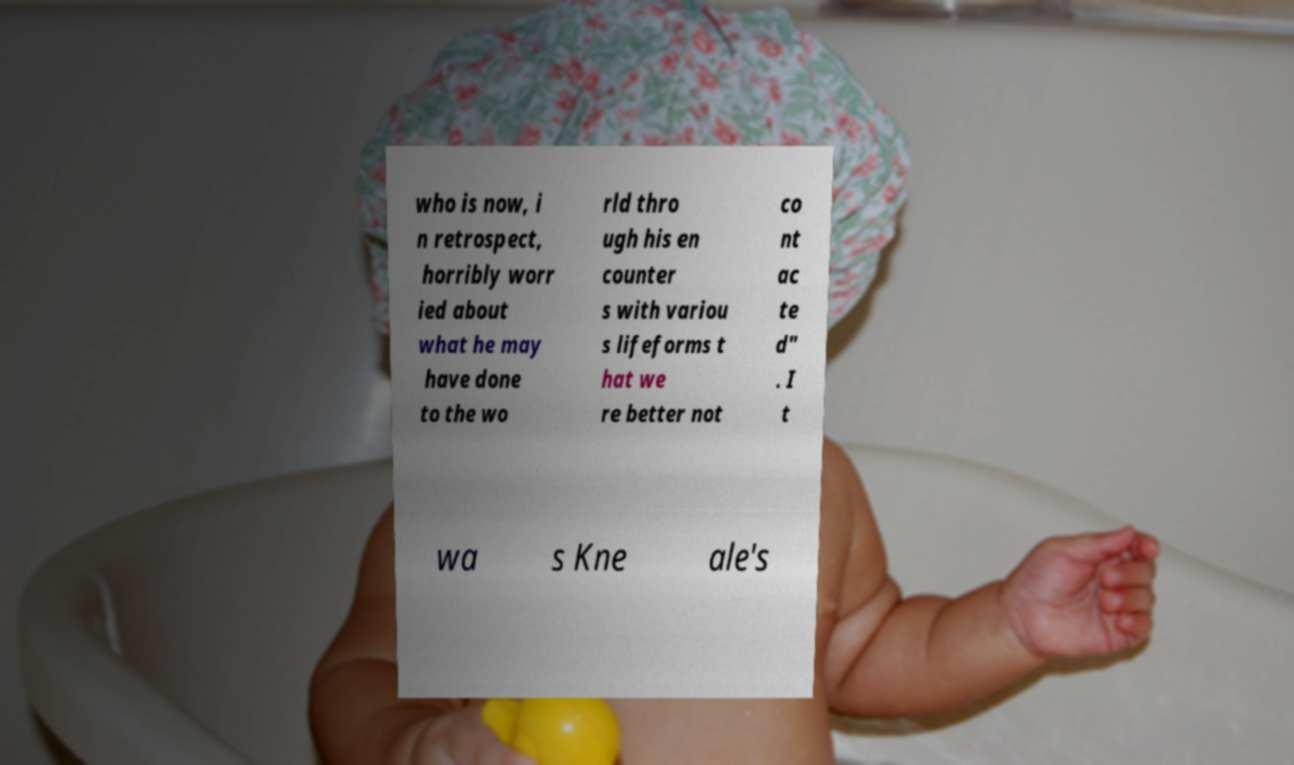What messages or text are displayed in this image? I need them in a readable, typed format. who is now, i n retrospect, horribly worr ied about what he may have done to the wo rld thro ugh his en counter s with variou s lifeforms t hat we re better not co nt ac te d" . I t wa s Kne ale's 